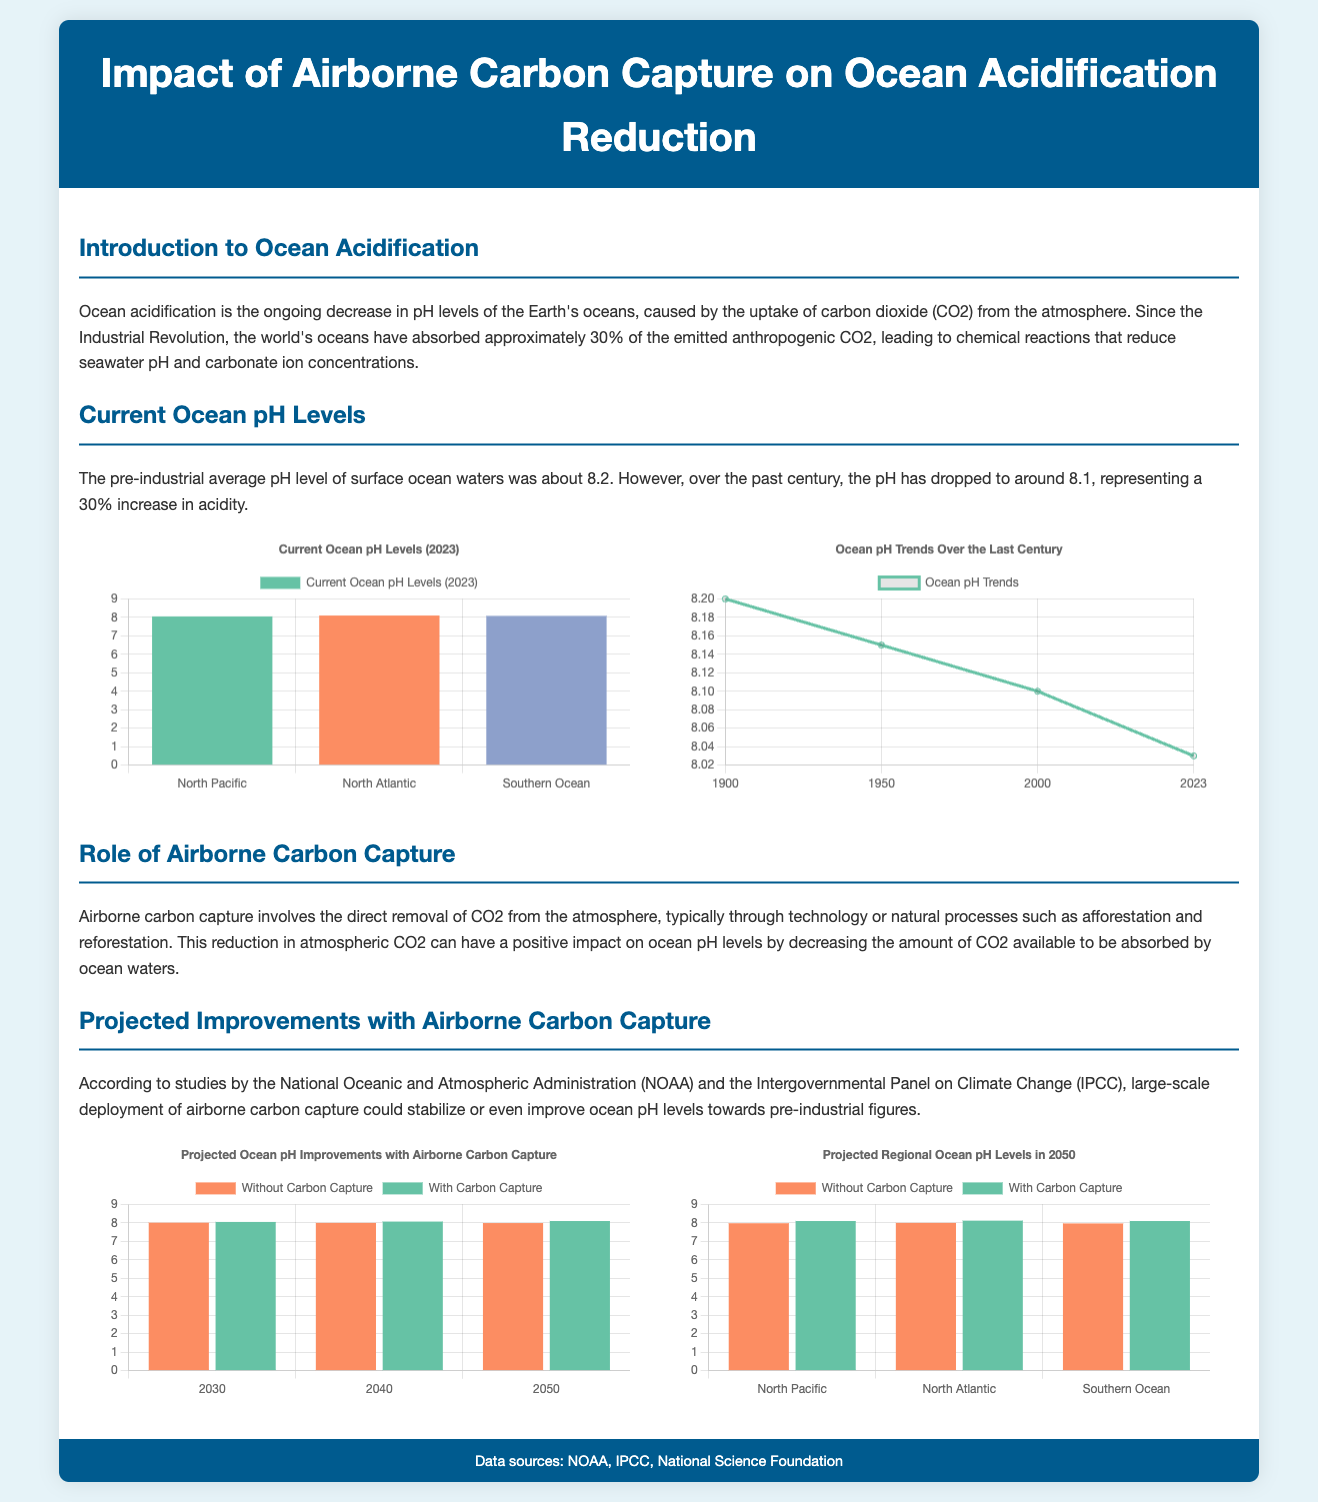what was the pre-industrial average pH level of ocean waters? The pre-industrial average pH level was about 8.2.
Answer: 8.2 what is the current pH level of the Southern Ocean in 2023? The current pH level of the Southern Ocean in 2023 is 8.08.
Answer: 8.08 how much has the ocean's acidity increased since the Industrial Revolution? The ocean's acidity has increased by 30%.
Answer: 30% what are the projected ocean pH levels in 2050 without carbon capture? The projected ocean pH levels in 2050 without carbon capture is 7.99.
Answer: 7.99 which dataset shows trends in ocean pH over the last century? The dataset labeled "Ocean pH Trends" displays the trends over the last century.
Answer: Ocean pH Trends what does the chart on projected improvements illustrate? The chart illustrates the projected ocean pH improvements with and without airborne carbon capture.
Answer: Projected ocean pH improvements how many regions are displayed in the regional projections chart? The regional projections chart displays three regions: North Pacific, North Atlantic, and Southern Ocean.
Answer: Three what is the projected ocean pH level for the North Atlantic in 2050 with carbon capture? The projected ocean pH level for the North Atlantic in 2050 with carbon capture is 8.12.
Answer: 8.12 how has the ocean pH trend changed from 2000 to 2023? The ocean pH trend decreased from 8.1 in 2000 to 8.03 in 2023.
Answer: Decreased 